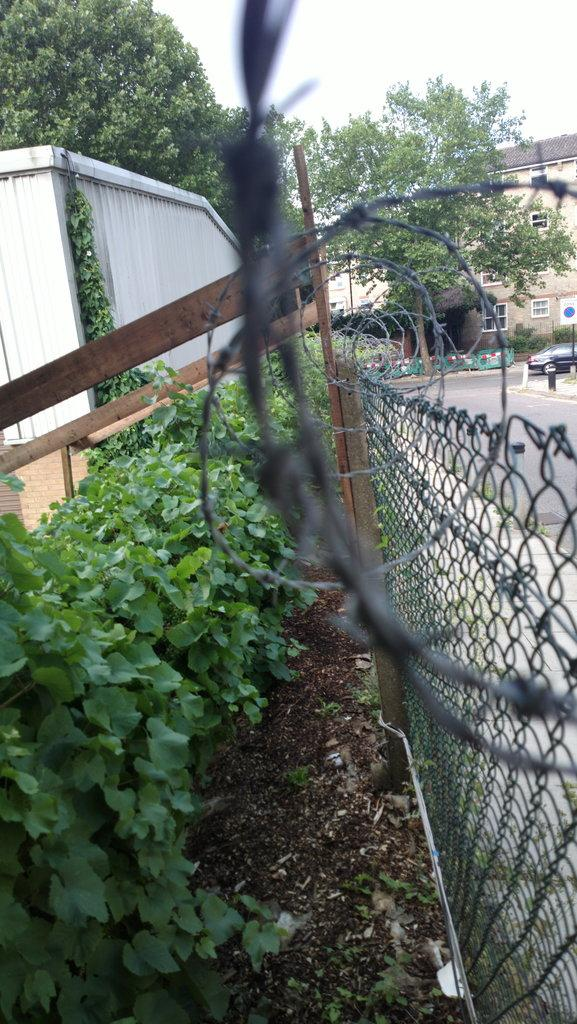What type of barrier can be seen in the image? There is a fence in the image. What type of natural elements are present in the image? There are plants and trees in the image. What type of material is used for the wooden planks in the image? The wooden planks in the image are made of wood. What type of object is made of metal in the image? There is a metal object in the image, but its specific purpose or function is not clear. What type of structures can be seen in the background of the image? There is a building and a board on a pole in the background of the image. What type of transportation is visible in the background of the image? There is a car on the road in the background of the image. What type of openings can be seen in the background of the image? There are windows visible in the background of the image. What type of natural phenomenon is visible in the background of the image? The sky is visible in the background of the image. What type of end can be seen in the image? There is no end present in the image. What type of discovery can be seen in the image? There is no discovery present in the image. What type of play can be seen in the image? There is no play present in the image. 